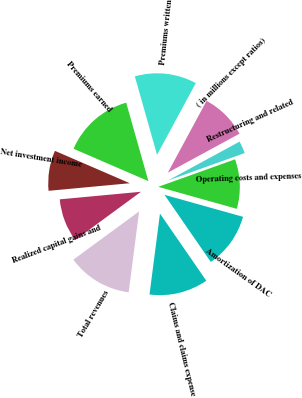<chart> <loc_0><loc_0><loc_500><loc_500><pie_chart><fcel>( in millions except ratios)<fcel>Premiums written<fcel>Premiums earned<fcel>Net investment income<fcel>Realized capital gains and<fcel>Total revenues<fcel>Claims and claims expense<fcel>Amortization of DAC<fcel>Operating costs and expenses<fcel>Restructuring and related<nl><fcel>9.2%<fcel>12.27%<fcel>14.11%<fcel>7.98%<fcel>8.59%<fcel>12.88%<fcel>11.66%<fcel>11.04%<fcel>9.82%<fcel>2.45%<nl></chart> 